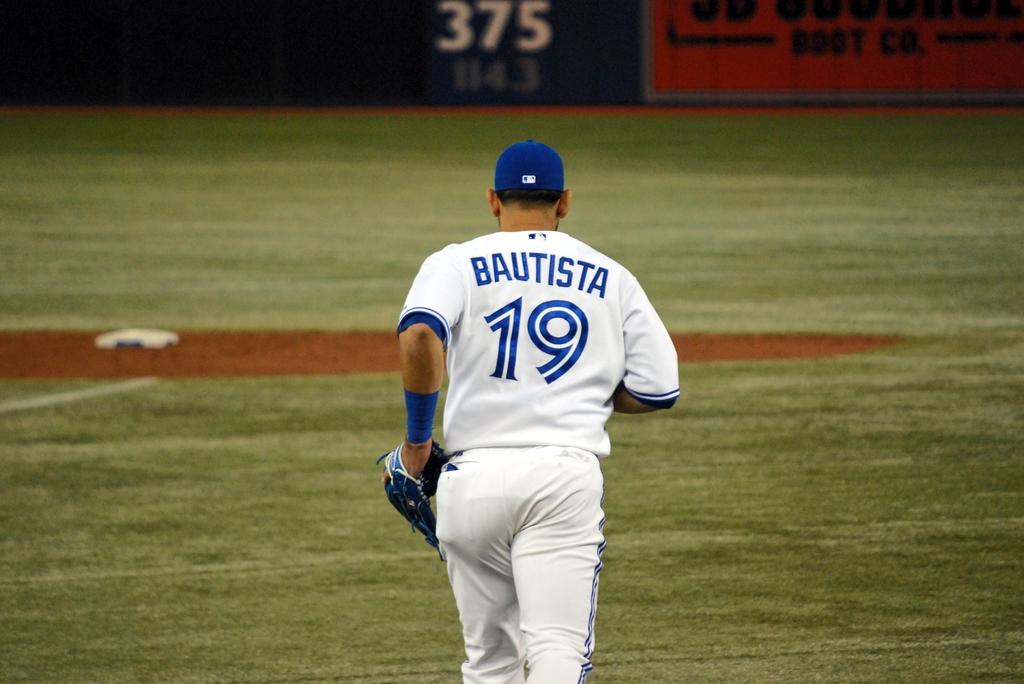What is that players number?
Your answer should be very brief. 19. 